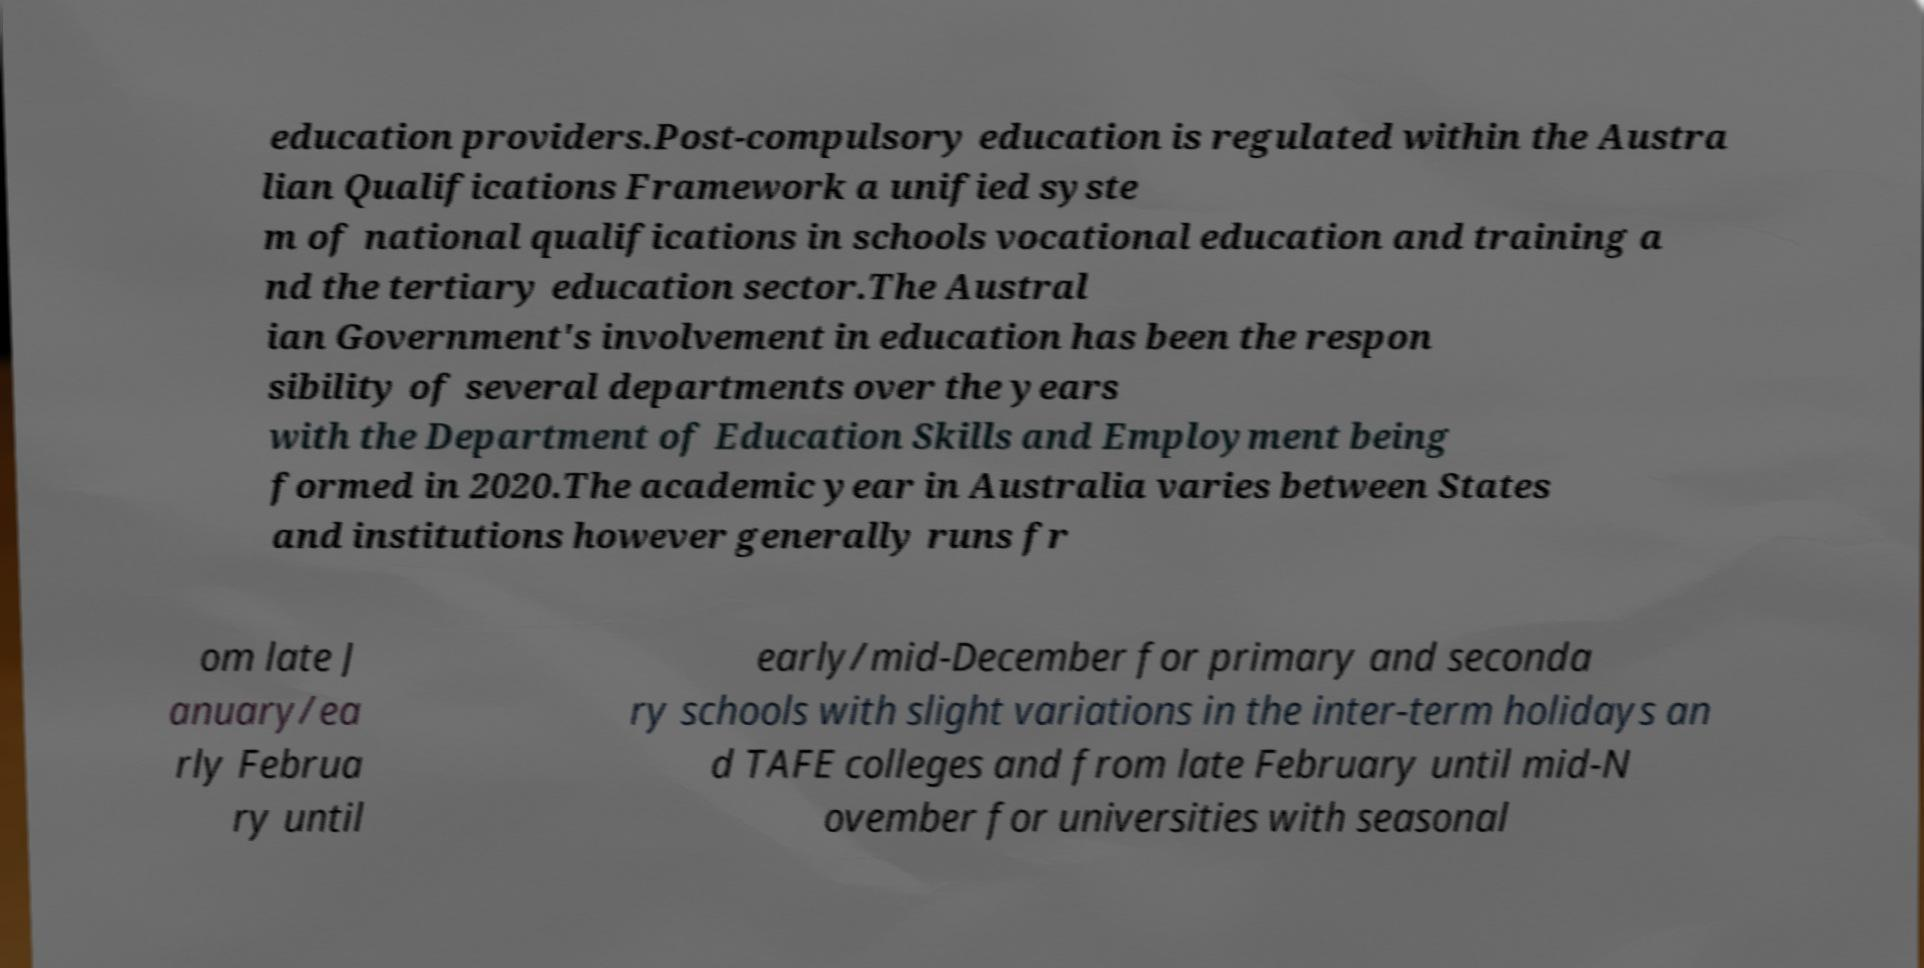Can you read and provide the text displayed in the image?This photo seems to have some interesting text. Can you extract and type it out for me? education providers.Post-compulsory education is regulated within the Austra lian Qualifications Framework a unified syste m of national qualifications in schools vocational education and training a nd the tertiary education sector.The Austral ian Government's involvement in education has been the respon sibility of several departments over the years with the Department of Education Skills and Employment being formed in 2020.The academic year in Australia varies between States and institutions however generally runs fr om late J anuary/ea rly Februa ry until early/mid-December for primary and seconda ry schools with slight variations in the inter-term holidays an d TAFE colleges and from late February until mid-N ovember for universities with seasonal 